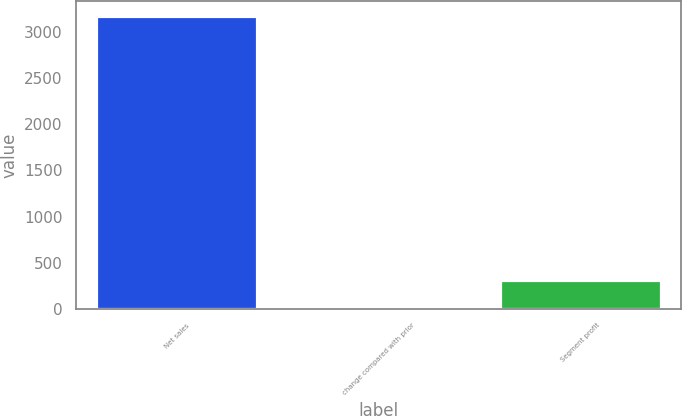<chart> <loc_0><loc_0><loc_500><loc_500><bar_chart><fcel>Net sales<fcel>change compared with prior<fcel>Segment profit<nl><fcel>3169<fcel>1<fcel>317.8<nl></chart> 